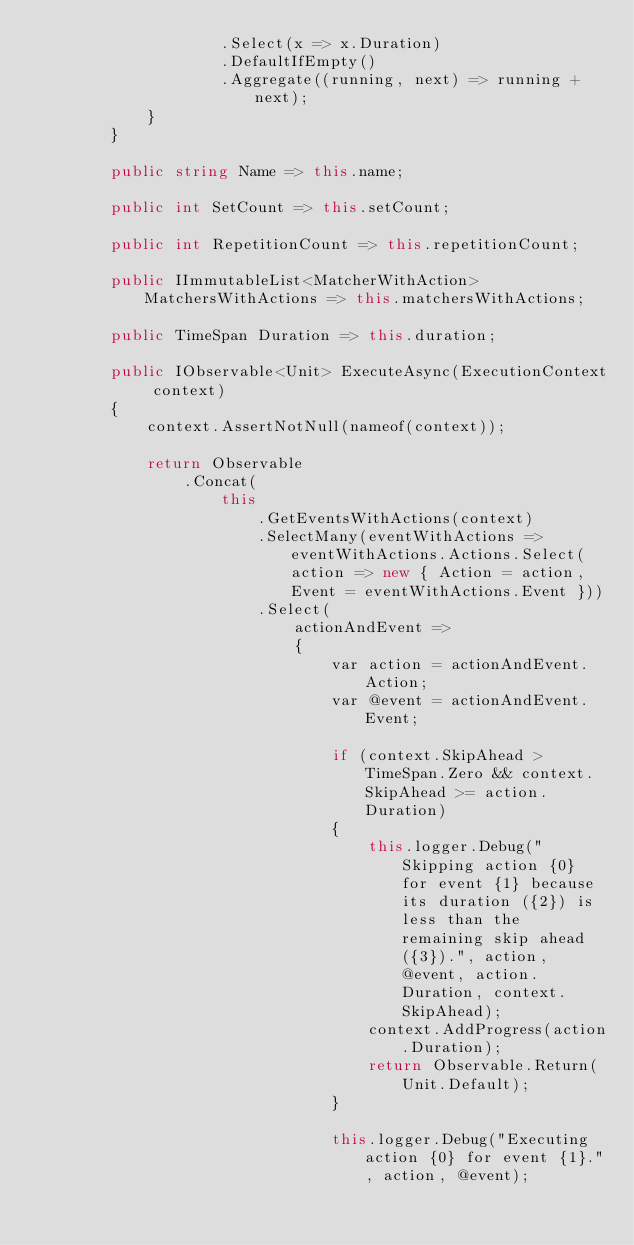<code> <loc_0><loc_0><loc_500><loc_500><_C#_>                    .Select(x => x.Duration)
                    .DefaultIfEmpty()
                    .Aggregate((running, next) => running + next);
            }
        }

        public string Name => this.name;

        public int SetCount => this.setCount;

        public int RepetitionCount => this.repetitionCount;

        public IImmutableList<MatcherWithAction> MatchersWithActions => this.matchersWithActions;

        public TimeSpan Duration => this.duration;

        public IObservable<Unit> ExecuteAsync(ExecutionContext context)
        {
            context.AssertNotNull(nameof(context));

            return Observable
                .Concat(
                    this
                        .GetEventsWithActions(context)
                        .SelectMany(eventWithActions => eventWithActions.Actions.Select(action => new { Action = action, Event = eventWithActions.Event }))
                        .Select(
                            actionAndEvent =>
                            {
                                var action = actionAndEvent.Action;
                                var @event = actionAndEvent.Event;

                                if (context.SkipAhead > TimeSpan.Zero && context.SkipAhead >= action.Duration)
                                {
                                    this.logger.Debug("Skipping action {0} for event {1} because its duration ({2}) is less than the remaining skip ahead ({3}).", action, @event, action.Duration, context.SkipAhead);
                                    context.AddProgress(action.Duration);
                                    return Observable.Return(Unit.Default);
                                }

                                this.logger.Debug("Executing action {0} for event {1}.", action, @event);</code> 